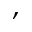Convert formula to latex. <formula><loc_0><loc_0><loc_500><loc_500>,</formula> 